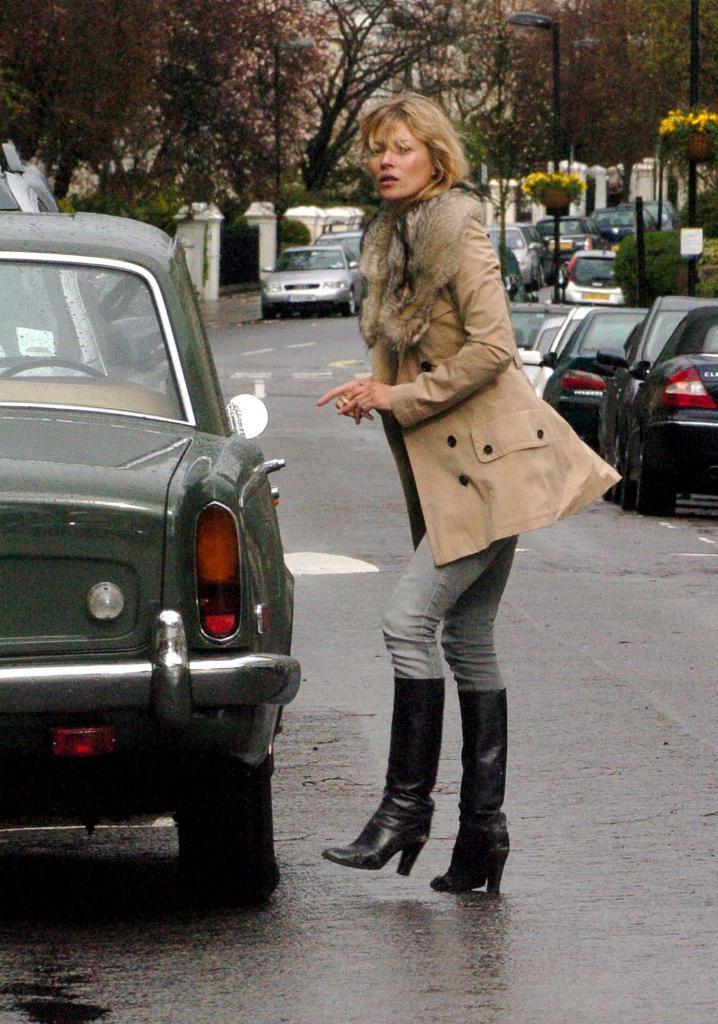Describe this image in one or two sentences. In this picture we can describe about a woman wearing a brown jacket and grey pant walking and looking into the camera. Beside we can see a old classic car on the road. Behind we can see many cars are parked at the roadside corner. In the background we can see black color light pole and many dry trees. 